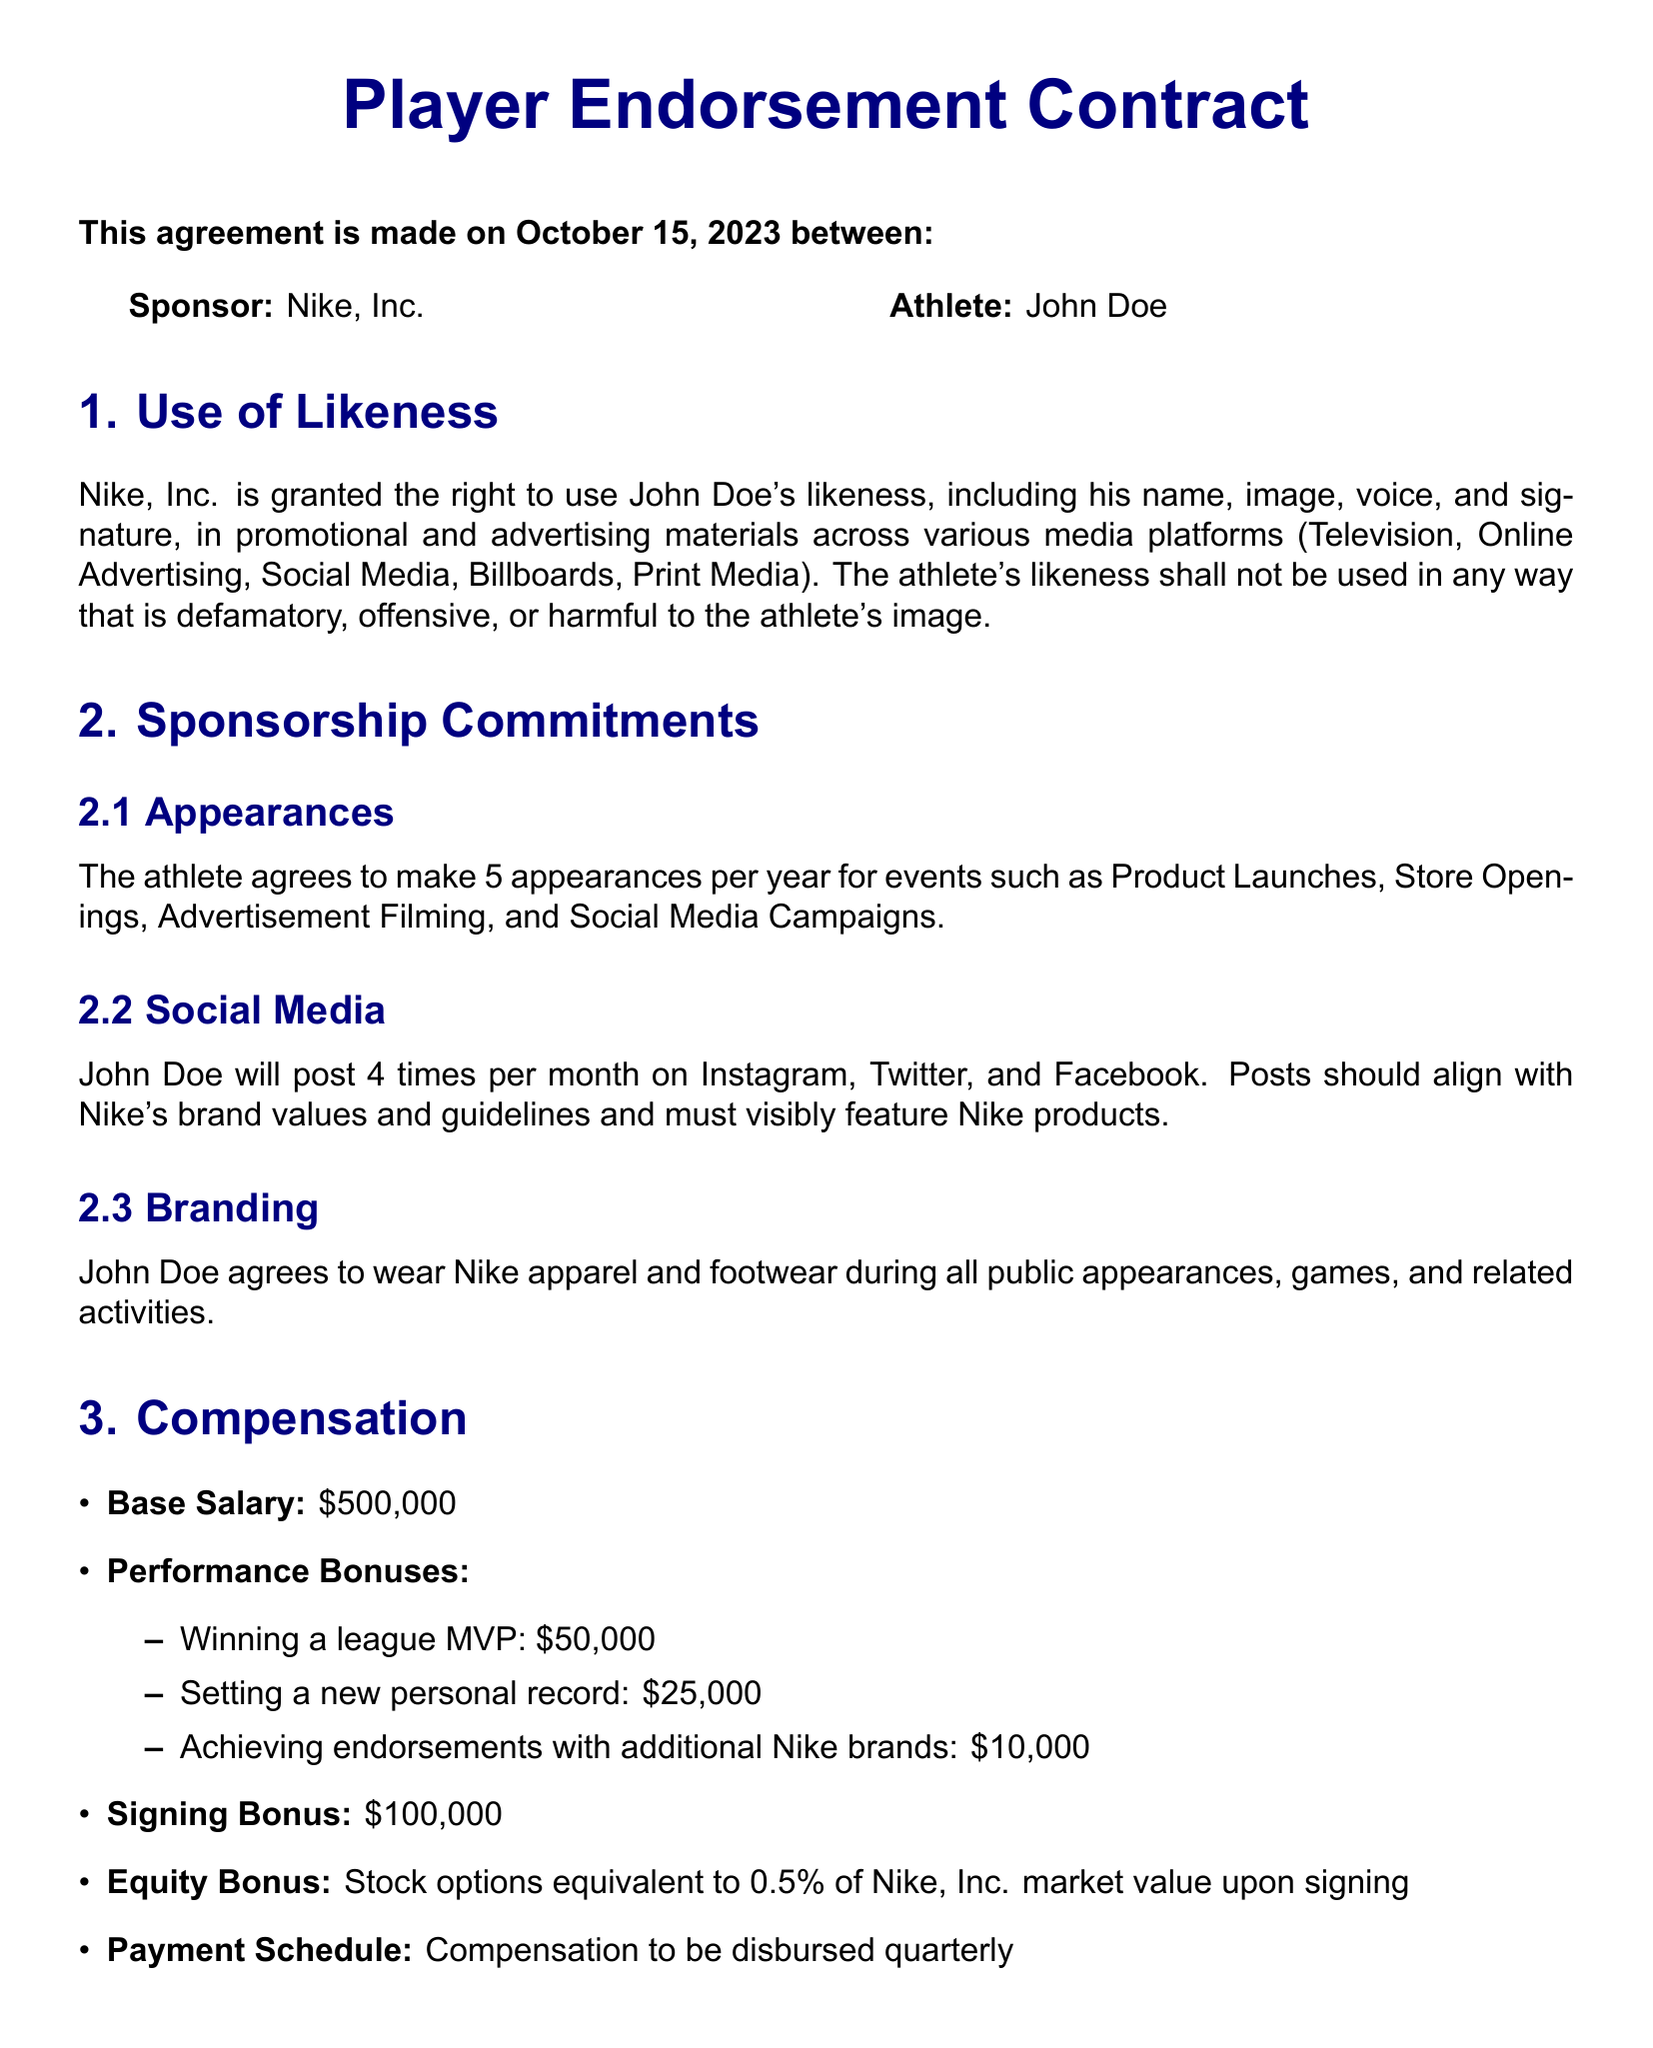What is the signing bonus? The signing bonus is a specific monetary compensation mentioned in the contract, representing an upfront payment.
Answer: $100,000 How many appearances will the athlete make per year? The contract specifies the number of appearances the athlete is obligated to make, which is laid out clearly in the sponsorship commitments section.
Answer: 5 What are the performance bonuses for winning a league MVP? The performance bonuses detail specific amounts the athlete can earn for achieving certain milestones, including one for winning a league MVP.
Answer: $50,000 What is the payment schedule for compensation? The payment schedule indicates how frequently the athlete will receive their compensation, providing clarity on disbursement timelines.
Answer: Quarterly What type of disputes are resolved through arbitration? This contract outlines how disputes related to its terms will be handled, highlighting the method of resolution stipulated in the miscellaneous section.
Answer: All disputes Which company is the sponsor of this endorsement contract? The document identifies the main party involved in the contract, who will be providing support to the athlete.
Answer: Nike, Inc What is John Doe required to wear during public appearances? The sponsorship commitments specify branding requirements that the athlete must adhere to during events and activities.
Answer: Nike apparel and footwear What is the governing law of this contract? The governing law specifies the legal jurisdiction under which any contract terms will be interpreted, which is a common clause in legal documents.
Answer: State of Oregon How often will John Doe post on social media? The contract specifies the frequency of social media engagement required from the athlete, one of the promotional commitments outlined.
Answer: 4 times per month 